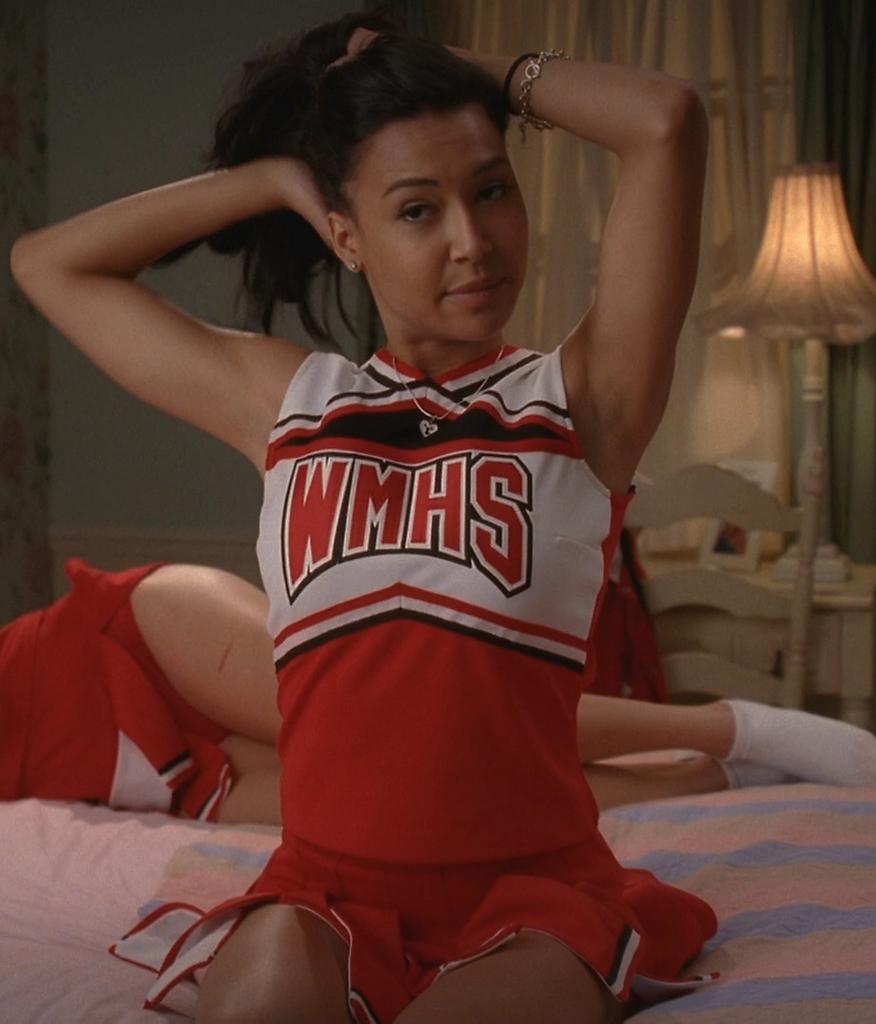What is the name of the highschool on her dress ?
Keep it short and to the point. Wmhs. 